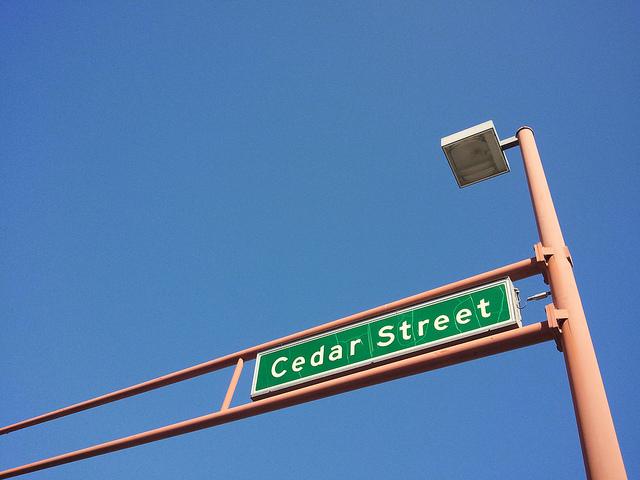What is the name of the street?
Give a very brief answer. Cedar. What is the street name?
Keep it brief. Cedar street. Does the light on the pole work?
Quick response, please. Yes. How many vertical poles are there?
Write a very short answer. 1. 